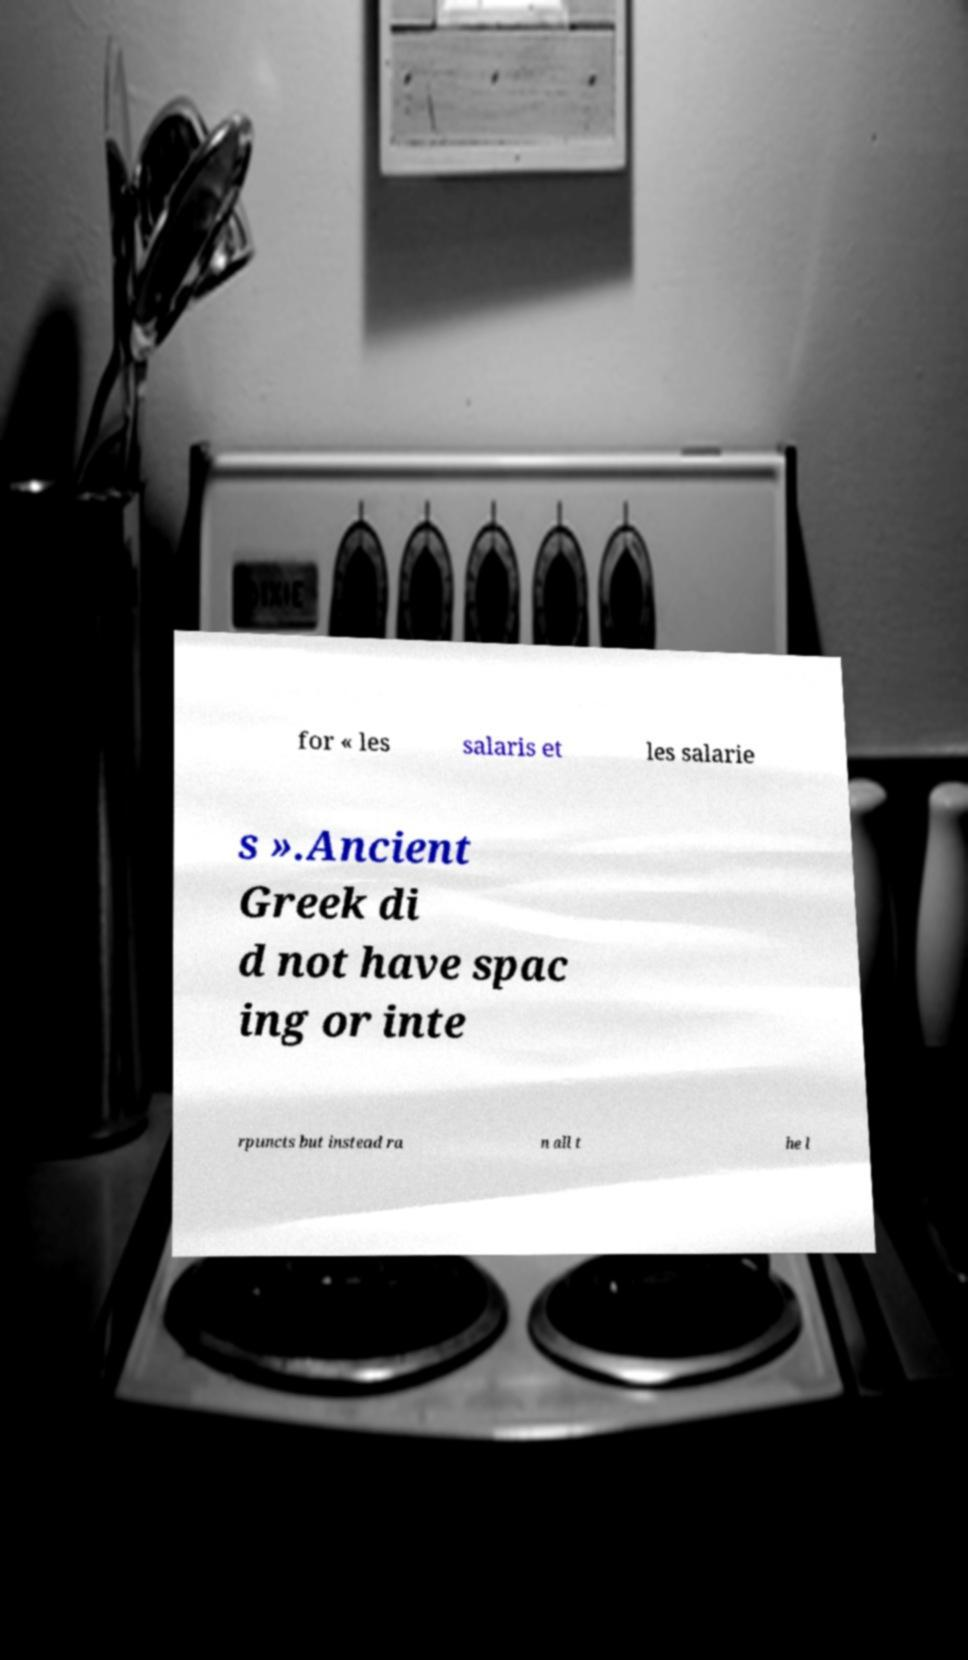Please identify and transcribe the text found in this image. for « les salaris et les salarie s ».Ancient Greek di d not have spac ing or inte rpuncts but instead ra n all t he l 